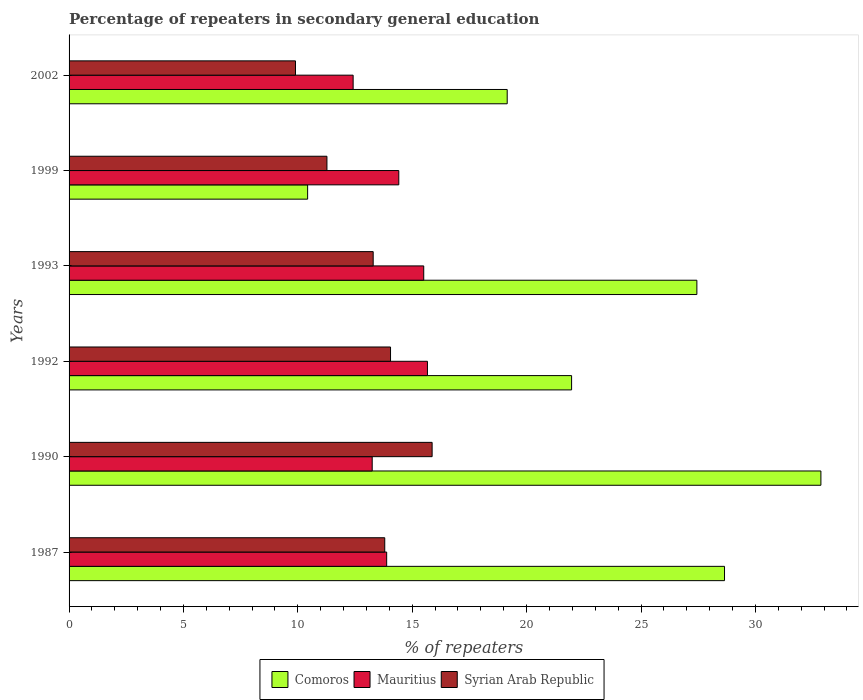How many different coloured bars are there?
Ensure brevity in your answer.  3. How many groups of bars are there?
Make the answer very short. 6. How many bars are there on the 2nd tick from the bottom?
Provide a short and direct response. 3. What is the percentage of repeaters in secondary general education in Syrian Arab Republic in 1992?
Make the answer very short. 14.05. Across all years, what is the maximum percentage of repeaters in secondary general education in Comoros?
Provide a succinct answer. 32.86. Across all years, what is the minimum percentage of repeaters in secondary general education in Mauritius?
Your response must be concise. 12.42. In which year was the percentage of repeaters in secondary general education in Syrian Arab Republic maximum?
Keep it short and to the point. 1990. In which year was the percentage of repeaters in secondary general education in Syrian Arab Republic minimum?
Give a very brief answer. 2002. What is the total percentage of repeaters in secondary general education in Comoros in the graph?
Provide a short and direct response. 140.5. What is the difference between the percentage of repeaters in secondary general education in Syrian Arab Republic in 1990 and that in 1999?
Offer a terse response. 4.6. What is the difference between the percentage of repeaters in secondary general education in Mauritius in 1990 and the percentage of repeaters in secondary general education in Comoros in 1992?
Offer a very short reply. -8.72. What is the average percentage of repeaters in secondary general education in Mauritius per year?
Offer a very short reply. 14.19. In the year 1987, what is the difference between the percentage of repeaters in secondary general education in Mauritius and percentage of repeaters in secondary general education in Syrian Arab Republic?
Provide a short and direct response. 0.08. What is the ratio of the percentage of repeaters in secondary general education in Comoros in 1992 to that in 1999?
Make the answer very short. 2.11. Is the percentage of repeaters in secondary general education in Syrian Arab Republic in 1990 less than that in 2002?
Your answer should be compact. No. What is the difference between the highest and the second highest percentage of repeaters in secondary general education in Syrian Arab Republic?
Make the answer very short. 1.82. What is the difference between the highest and the lowest percentage of repeaters in secondary general education in Comoros?
Offer a terse response. 22.44. Is the sum of the percentage of repeaters in secondary general education in Comoros in 1992 and 1993 greater than the maximum percentage of repeaters in secondary general education in Syrian Arab Republic across all years?
Your response must be concise. Yes. What does the 2nd bar from the top in 1993 represents?
Offer a very short reply. Mauritius. What does the 2nd bar from the bottom in 1999 represents?
Offer a terse response. Mauritius. Are all the bars in the graph horizontal?
Make the answer very short. Yes. How many years are there in the graph?
Provide a short and direct response. 6. What is the difference between two consecutive major ticks on the X-axis?
Give a very brief answer. 5. Does the graph contain grids?
Your answer should be very brief. No. How many legend labels are there?
Give a very brief answer. 3. What is the title of the graph?
Your response must be concise. Percentage of repeaters in secondary general education. Does "Djibouti" appear as one of the legend labels in the graph?
Provide a short and direct response. No. What is the label or title of the X-axis?
Keep it short and to the point. % of repeaters. What is the % of repeaters of Comoros in 1987?
Keep it short and to the point. 28.65. What is the % of repeaters in Mauritius in 1987?
Give a very brief answer. 13.88. What is the % of repeaters of Syrian Arab Republic in 1987?
Your answer should be very brief. 13.8. What is the % of repeaters in Comoros in 1990?
Your answer should be very brief. 32.86. What is the % of repeaters of Mauritius in 1990?
Offer a very short reply. 13.25. What is the % of repeaters of Syrian Arab Republic in 1990?
Offer a terse response. 15.87. What is the % of repeaters of Comoros in 1992?
Your response must be concise. 21.97. What is the % of repeaters in Mauritius in 1992?
Give a very brief answer. 15.67. What is the % of repeaters in Syrian Arab Republic in 1992?
Your response must be concise. 14.05. What is the % of repeaters of Comoros in 1993?
Provide a short and direct response. 27.44. What is the % of repeaters in Mauritius in 1993?
Give a very brief answer. 15.5. What is the % of repeaters in Syrian Arab Republic in 1993?
Ensure brevity in your answer.  13.29. What is the % of repeaters in Comoros in 1999?
Ensure brevity in your answer.  10.43. What is the % of repeaters in Mauritius in 1999?
Give a very brief answer. 14.41. What is the % of repeaters in Syrian Arab Republic in 1999?
Give a very brief answer. 11.27. What is the % of repeaters in Comoros in 2002?
Provide a short and direct response. 19.15. What is the % of repeaters in Mauritius in 2002?
Make the answer very short. 12.42. What is the % of repeaters of Syrian Arab Republic in 2002?
Make the answer very short. 9.9. Across all years, what is the maximum % of repeaters in Comoros?
Keep it short and to the point. 32.86. Across all years, what is the maximum % of repeaters of Mauritius?
Your answer should be compact. 15.67. Across all years, what is the maximum % of repeaters of Syrian Arab Republic?
Give a very brief answer. 15.87. Across all years, what is the minimum % of repeaters in Comoros?
Your answer should be very brief. 10.43. Across all years, what is the minimum % of repeaters of Mauritius?
Ensure brevity in your answer.  12.42. Across all years, what is the minimum % of repeaters in Syrian Arab Republic?
Your answer should be compact. 9.9. What is the total % of repeaters of Comoros in the graph?
Your answer should be very brief. 140.5. What is the total % of repeaters in Mauritius in the graph?
Make the answer very short. 85.13. What is the total % of repeaters of Syrian Arab Republic in the graph?
Keep it short and to the point. 78.18. What is the difference between the % of repeaters in Comoros in 1987 and that in 1990?
Offer a terse response. -4.21. What is the difference between the % of repeaters of Mauritius in 1987 and that in 1990?
Ensure brevity in your answer.  0.63. What is the difference between the % of repeaters in Syrian Arab Republic in 1987 and that in 1990?
Give a very brief answer. -2.07. What is the difference between the % of repeaters of Comoros in 1987 and that in 1992?
Offer a terse response. 6.68. What is the difference between the % of repeaters of Mauritius in 1987 and that in 1992?
Make the answer very short. -1.78. What is the difference between the % of repeaters in Syrian Arab Republic in 1987 and that in 1992?
Your answer should be very brief. -0.25. What is the difference between the % of repeaters of Comoros in 1987 and that in 1993?
Your answer should be compact. 1.21. What is the difference between the % of repeaters of Mauritius in 1987 and that in 1993?
Offer a terse response. -1.62. What is the difference between the % of repeaters of Syrian Arab Republic in 1987 and that in 1993?
Make the answer very short. 0.51. What is the difference between the % of repeaters of Comoros in 1987 and that in 1999?
Provide a short and direct response. 18.22. What is the difference between the % of repeaters in Mauritius in 1987 and that in 1999?
Offer a terse response. -0.53. What is the difference between the % of repeaters of Syrian Arab Republic in 1987 and that in 1999?
Offer a very short reply. 2.53. What is the difference between the % of repeaters of Comoros in 1987 and that in 2002?
Keep it short and to the point. 9.5. What is the difference between the % of repeaters of Mauritius in 1987 and that in 2002?
Offer a very short reply. 1.47. What is the difference between the % of repeaters of Syrian Arab Republic in 1987 and that in 2002?
Offer a very short reply. 3.9. What is the difference between the % of repeaters of Comoros in 1990 and that in 1992?
Offer a very short reply. 10.9. What is the difference between the % of repeaters of Mauritius in 1990 and that in 1992?
Give a very brief answer. -2.42. What is the difference between the % of repeaters in Syrian Arab Republic in 1990 and that in 1992?
Your response must be concise. 1.82. What is the difference between the % of repeaters of Comoros in 1990 and that in 1993?
Your answer should be compact. 5.42. What is the difference between the % of repeaters of Mauritius in 1990 and that in 1993?
Ensure brevity in your answer.  -2.25. What is the difference between the % of repeaters in Syrian Arab Republic in 1990 and that in 1993?
Give a very brief answer. 2.58. What is the difference between the % of repeaters in Comoros in 1990 and that in 1999?
Keep it short and to the point. 22.44. What is the difference between the % of repeaters in Mauritius in 1990 and that in 1999?
Make the answer very short. -1.16. What is the difference between the % of repeaters of Syrian Arab Republic in 1990 and that in 1999?
Make the answer very short. 4.6. What is the difference between the % of repeaters of Comoros in 1990 and that in 2002?
Give a very brief answer. 13.71. What is the difference between the % of repeaters in Mauritius in 1990 and that in 2002?
Your answer should be very brief. 0.83. What is the difference between the % of repeaters of Syrian Arab Republic in 1990 and that in 2002?
Your response must be concise. 5.97. What is the difference between the % of repeaters of Comoros in 1992 and that in 1993?
Provide a succinct answer. -5.48. What is the difference between the % of repeaters of Mauritius in 1992 and that in 1993?
Offer a terse response. 0.16. What is the difference between the % of repeaters in Syrian Arab Republic in 1992 and that in 1993?
Ensure brevity in your answer.  0.76. What is the difference between the % of repeaters of Comoros in 1992 and that in 1999?
Make the answer very short. 11.54. What is the difference between the % of repeaters in Mauritius in 1992 and that in 1999?
Offer a very short reply. 1.25. What is the difference between the % of repeaters in Syrian Arab Republic in 1992 and that in 1999?
Make the answer very short. 2.78. What is the difference between the % of repeaters in Comoros in 1992 and that in 2002?
Your answer should be very brief. 2.81. What is the difference between the % of repeaters of Mauritius in 1992 and that in 2002?
Provide a short and direct response. 3.25. What is the difference between the % of repeaters in Syrian Arab Republic in 1992 and that in 2002?
Offer a very short reply. 4.15. What is the difference between the % of repeaters in Comoros in 1993 and that in 1999?
Provide a succinct answer. 17.01. What is the difference between the % of repeaters in Mauritius in 1993 and that in 1999?
Keep it short and to the point. 1.09. What is the difference between the % of repeaters in Syrian Arab Republic in 1993 and that in 1999?
Keep it short and to the point. 2.02. What is the difference between the % of repeaters in Comoros in 1993 and that in 2002?
Your response must be concise. 8.29. What is the difference between the % of repeaters in Mauritius in 1993 and that in 2002?
Keep it short and to the point. 3.09. What is the difference between the % of repeaters of Syrian Arab Republic in 1993 and that in 2002?
Offer a terse response. 3.4. What is the difference between the % of repeaters in Comoros in 1999 and that in 2002?
Your response must be concise. -8.72. What is the difference between the % of repeaters of Mauritius in 1999 and that in 2002?
Keep it short and to the point. 2. What is the difference between the % of repeaters in Syrian Arab Republic in 1999 and that in 2002?
Keep it short and to the point. 1.38. What is the difference between the % of repeaters in Comoros in 1987 and the % of repeaters in Mauritius in 1990?
Offer a terse response. 15.4. What is the difference between the % of repeaters of Comoros in 1987 and the % of repeaters of Syrian Arab Republic in 1990?
Offer a terse response. 12.78. What is the difference between the % of repeaters in Mauritius in 1987 and the % of repeaters in Syrian Arab Republic in 1990?
Ensure brevity in your answer.  -1.99. What is the difference between the % of repeaters of Comoros in 1987 and the % of repeaters of Mauritius in 1992?
Provide a short and direct response. 12.98. What is the difference between the % of repeaters in Comoros in 1987 and the % of repeaters in Syrian Arab Republic in 1992?
Make the answer very short. 14.6. What is the difference between the % of repeaters in Mauritius in 1987 and the % of repeaters in Syrian Arab Republic in 1992?
Your answer should be very brief. -0.17. What is the difference between the % of repeaters in Comoros in 1987 and the % of repeaters in Mauritius in 1993?
Your response must be concise. 13.15. What is the difference between the % of repeaters of Comoros in 1987 and the % of repeaters of Syrian Arab Republic in 1993?
Your response must be concise. 15.36. What is the difference between the % of repeaters of Mauritius in 1987 and the % of repeaters of Syrian Arab Republic in 1993?
Keep it short and to the point. 0.59. What is the difference between the % of repeaters in Comoros in 1987 and the % of repeaters in Mauritius in 1999?
Provide a short and direct response. 14.24. What is the difference between the % of repeaters of Comoros in 1987 and the % of repeaters of Syrian Arab Republic in 1999?
Make the answer very short. 17.38. What is the difference between the % of repeaters in Mauritius in 1987 and the % of repeaters in Syrian Arab Republic in 1999?
Provide a short and direct response. 2.61. What is the difference between the % of repeaters of Comoros in 1987 and the % of repeaters of Mauritius in 2002?
Provide a succinct answer. 16.23. What is the difference between the % of repeaters of Comoros in 1987 and the % of repeaters of Syrian Arab Republic in 2002?
Make the answer very short. 18.75. What is the difference between the % of repeaters of Mauritius in 1987 and the % of repeaters of Syrian Arab Republic in 2002?
Keep it short and to the point. 3.99. What is the difference between the % of repeaters of Comoros in 1990 and the % of repeaters of Mauritius in 1992?
Provide a succinct answer. 17.2. What is the difference between the % of repeaters in Comoros in 1990 and the % of repeaters in Syrian Arab Republic in 1992?
Ensure brevity in your answer.  18.81. What is the difference between the % of repeaters in Mauritius in 1990 and the % of repeaters in Syrian Arab Republic in 1992?
Give a very brief answer. -0.8. What is the difference between the % of repeaters of Comoros in 1990 and the % of repeaters of Mauritius in 1993?
Give a very brief answer. 17.36. What is the difference between the % of repeaters of Comoros in 1990 and the % of repeaters of Syrian Arab Republic in 1993?
Your answer should be very brief. 19.57. What is the difference between the % of repeaters of Mauritius in 1990 and the % of repeaters of Syrian Arab Republic in 1993?
Offer a very short reply. -0.04. What is the difference between the % of repeaters in Comoros in 1990 and the % of repeaters in Mauritius in 1999?
Offer a terse response. 18.45. What is the difference between the % of repeaters of Comoros in 1990 and the % of repeaters of Syrian Arab Republic in 1999?
Offer a very short reply. 21.59. What is the difference between the % of repeaters in Mauritius in 1990 and the % of repeaters in Syrian Arab Republic in 1999?
Your answer should be compact. 1.98. What is the difference between the % of repeaters in Comoros in 1990 and the % of repeaters in Mauritius in 2002?
Offer a terse response. 20.45. What is the difference between the % of repeaters in Comoros in 1990 and the % of repeaters in Syrian Arab Republic in 2002?
Keep it short and to the point. 22.97. What is the difference between the % of repeaters of Mauritius in 1990 and the % of repeaters of Syrian Arab Republic in 2002?
Your answer should be very brief. 3.35. What is the difference between the % of repeaters of Comoros in 1992 and the % of repeaters of Mauritius in 1993?
Provide a short and direct response. 6.46. What is the difference between the % of repeaters in Comoros in 1992 and the % of repeaters in Syrian Arab Republic in 1993?
Your answer should be very brief. 8.67. What is the difference between the % of repeaters of Mauritius in 1992 and the % of repeaters of Syrian Arab Republic in 1993?
Offer a terse response. 2.37. What is the difference between the % of repeaters in Comoros in 1992 and the % of repeaters in Mauritius in 1999?
Your response must be concise. 7.55. What is the difference between the % of repeaters of Comoros in 1992 and the % of repeaters of Syrian Arab Republic in 1999?
Your response must be concise. 10.69. What is the difference between the % of repeaters in Mauritius in 1992 and the % of repeaters in Syrian Arab Republic in 1999?
Give a very brief answer. 4.39. What is the difference between the % of repeaters in Comoros in 1992 and the % of repeaters in Mauritius in 2002?
Your answer should be compact. 9.55. What is the difference between the % of repeaters of Comoros in 1992 and the % of repeaters of Syrian Arab Republic in 2002?
Keep it short and to the point. 12.07. What is the difference between the % of repeaters in Mauritius in 1992 and the % of repeaters in Syrian Arab Republic in 2002?
Your answer should be very brief. 5.77. What is the difference between the % of repeaters in Comoros in 1993 and the % of repeaters in Mauritius in 1999?
Keep it short and to the point. 13.03. What is the difference between the % of repeaters of Comoros in 1993 and the % of repeaters of Syrian Arab Republic in 1999?
Provide a short and direct response. 16.17. What is the difference between the % of repeaters of Mauritius in 1993 and the % of repeaters of Syrian Arab Republic in 1999?
Provide a short and direct response. 4.23. What is the difference between the % of repeaters in Comoros in 1993 and the % of repeaters in Mauritius in 2002?
Give a very brief answer. 15.03. What is the difference between the % of repeaters of Comoros in 1993 and the % of repeaters of Syrian Arab Republic in 2002?
Your answer should be very brief. 17.55. What is the difference between the % of repeaters of Mauritius in 1993 and the % of repeaters of Syrian Arab Republic in 2002?
Your response must be concise. 5.61. What is the difference between the % of repeaters in Comoros in 1999 and the % of repeaters in Mauritius in 2002?
Your answer should be compact. -1.99. What is the difference between the % of repeaters of Comoros in 1999 and the % of repeaters of Syrian Arab Republic in 2002?
Offer a terse response. 0.53. What is the difference between the % of repeaters of Mauritius in 1999 and the % of repeaters of Syrian Arab Republic in 2002?
Provide a short and direct response. 4.52. What is the average % of repeaters of Comoros per year?
Offer a very short reply. 23.42. What is the average % of repeaters of Mauritius per year?
Your answer should be compact. 14.19. What is the average % of repeaters of Syrian Arab Republic per year?
Offer a terse response. 13.03. In the year 1987, what is the difference between the % of repeaters of Comoros and % of repeaters of Mauritius?
Your answer should be very brief. 14.77. In the year 1987, what is the difference between the % of repeaters of Comoros and % of repeaters of Syrian Arab Republic?
Give a very brief answer. 14.85. In the year 1987, what is the difference between the % of repeaters in Mauritius and % of repeaters in Syrian Arab Republic?
Offer a very short reply. 0.08. In the year 1990, what is the difference between the % of repeaters of Comoros and % of repeaters of Mauritius?
Offer a very short reply. 19.61. In the year 1990, what is the difference between the % of repeaters in Comoros and % of repeaters in Syrian Arab Republic?
Make the answer very short. 16.99. In the year 1990, what is the difference between the % of repeaters in Mauritius and % of repeaters in Syrian Arab Republic?
Your answer should be very brief. -2.62. In the year 1992, what is the difference between the % of repeaters of Comoros and % of repeaters of Mauritius?
Offer a terse response. 6.3. In the year 1992, what is the difference between the % of repeaters in Comoros and % of repeaters in Syrian Arab Republic?
Provide a short and direct response. 7.91. In the year 1992, what is the difference between the % of repeaters of Mauritius and % of repeaters of Syrian Arab Republic?
Ensure brevity in your answer.  1.61. In the year 1993, what is the difference between the % of repeaters in Comoros and % of repeaters in Mauritius?
Give a very brief answer. 11.94. In the year 1993, what is the difference between the % of repeaters in Comoros and % of repeaters in Syrian Arab Republic?
Your answer should be very brief. 14.15. In the year 1993, what is the difference between the % of repeaters of Mauritius and % of repeaters of Syrian Arab Republic?
Offer a terse response. 2.21. In the year 1999, what is the difference between the % of repeaters of Comoros and % of repeaters of Mauritius?
Give a very brief answer. -3.99. In the year 1999, what is the difference between the % of repeaters in Comoros and % of repeaters in Syrian Arab Republic?
Give a very brief answer. -0.84. In the year 1999, what is the difference between the % of repeaters in Mauritius and % of repeaters in Syrian Arab Republic?
Ensure brevity in your answer.  3.14. In the year 2002, what is the difference between the % of repeaters in Comoros and % of repeaters in Mauritius?
Keep it short and to the point. 6.73. In the year 2002, what is the difference between the % of repeaters of Comoros and % of repeaters of Syrian Arab Republic?
Ensure brevity in your answer.  9.25. In the year 2002, what is the difference between the % of repeaters in Mauritius and % of repeaters in Syrian Arab Republic?
Offer a terse response. 2.52. What is the ratio of the % of repeaters of Comoros in 1987 to that in 1990?
Ensure brevity in your answer.  0.87. What is the ratio of the % of repeaters of Mauritius in 1987 to that in 1990?
Your answer should be compact. 1.05. What is the ratio of the % of repeaters in Syrian Arab Republic in 1987 to that in 1990?
Give a very brief answer. 0.87. What is the ratio of the % of repeaters in Comoros in 1987 to that in 1992?
Keep it short and to the point. 1.3. What is the ratio of the % of repeaters of Mauritius in 1987 to that in 1992?
Provide a succinct answer. 0.89. What is the ratio of the % of repeaters of Syrian Arab Republic in 1987 to that in 1992?
Make the answer very short. 0.98. What is the ratio of the % of repeaters of Comoros in 1987 to that in 1993?
Give a very brief answer. 1.04. What is the ratio of the % of repeaters in Mauritius in 1987 to that in 1993?
Your response must be concise. 0.9. What is the ratio of the % of repeaters in Syrian Arab Republic in 1987 to that in 1993?
Your answer should be compact. 1.04. What is the ratio of the % of repeaters in Comoros in 1987 to that in 1999?
Ensure brevity in your answer.  2.75. What is the ratio of the % of repeaters in Mauritius in 1987 to that in 1999?
Make the answer very short. 0.96. What is the ratio of the % of repeaters of Syrian Arab Republic in 1987 to that in 1999?
Make the answer very short. 1.22. What is the ratio of the % of repeaters of Comoros in 1987 to that in 2002?
Ensure brevity in your answer.  1.5. What is the ratio of the % of repeaters of Mauritius in 1987 to that in 2002?
Offer a very short reply. 1.12. What is the ratio of the % of repeaters of Syrian Arab Republic in 1987 to that in 2002?
Ensure brevity in your answer.  1.39. What is the ratio of the % of repeaters of Comoros in 1990 to that in 1992?
Make the answer very short. 1.5. What is the ratio of the % of repeaters in Mauritius in 1990 to that in 1992?
Your answer should be very brief. 0.85. What is the ratio of the % of repeaters of Syrian Arab Republic in 1990 to that in 1992?
Keep it short and to the point. 1.13. What is the ratio of the % of repeaters in Comoros in 1990 to that in 1993?
Offer a terse response. 1.2. What is the ratio of the % of repeaters of Mauritius in 1990 to that in 1993?
Give a very brief answer. 0.85. What is the ratio of the % of repeaters in Syrian Arab Republic in 1990 to that in 1993?
Your answer should be compact. 1.19. What is the ratio of the % of repeaters in Comoros in 1990 to that in 1999?
Give a very brief answer. 3.15. What is the ratio of the % of repeaters of Mauritius in 1990 to that in 1999?
Your response must be concise. 0.92. What is the ratio of the % of repeaters in Syrian Arab Republic in 1990 to that in 1999?
Ensure brevity in your answer.  1.41. What is the ratio of the % of repeaters of Comoros in 1990 to that in 2002?
Offer a very short reply. 1.72. What is the ratio of the % of repeaters in Mauritius in 1990 to that in 2002?
Provide a succinct answer. 1.07. What is the ratio of the % of repeaters of Syrian Arab Republic in 1990 to that in 2002?
Ensure brevity in your answer.  1.6. What is the ratio of the % of repeaters of Comoros in 1992 to that in 1993?
Your response must be concise. 0.8. What is the ratio of the % of repeaters of Mauritius in 1992 to that in 1993?
Make the answer very short. 1.01. What is the ratio of the % of repeaters of Syrian Arab Republic in 1992 to that in 1993?
Provide a succinct answer. 1.06. What is the ratio of the % of repeaters of Comoros in 1992 to that in 1999?
Your answer should be compact. 2.11. What is the ratio of the % of repeaters of Mauritius in 1992 to that in 1999?
Offer a terse response. 1.09. What is the ratio of the % of repeaters of Syrian Arab Republic in 1992 to that in 1999?
Your answer should be very brief. 1.25. What is the ratio of the % of repeaters of Comoros in 1992 to that in 2002?
Your answer should be very brief. 1.15. What is the ratio of the % of repeaters of Mauritius in 1992 to that in 2002?
Keep it short and to the point. 1.26. What is the ratio of the % of repeaters in Syrian Arab Republic in 1992 to that in 2002?
Keep it short and to the point. 1.42. What is the ratio of the % of repeaters of Comoros in 1993 to that in 1999?
Your answer should be very brief. 2.63. What is the ratio of the % of repeaters in Mauritius in 1993 to that in 1999?
Offer a very short reply. 1.08. What is the ratio of the % of repeaters of Syrian Arab Republic in 1993 to that in 1999?
Give a very brief answer. 1.18. What is the ratio of the % of repeaters of Comoros in 1993 to that in 2002?
Your answer should be compact. 1.43. What is the ratio of the % of repeaters of Mauritius in 1993 to that in 2002?
Offer a very short reply. 1.25. What is the ratio of the % of repeaters in Syrian Arab Republic in 1993 to that in 2002?
Give a very brief answer. 1.34. What is the ratio of the % of repeaters in Comoros in 1999 to that in 2002?
Keep it short and to the point. 0.54. What is the ratio of the % of repeaters in Mauritius in 1999 to that in 2002?
Give a very brief answer. 1.16. What is the ratio of the % of repeaters in Syrian Arab Republic in 1999 to that in 2002?
Ensure brevity in your answer.  1.14. What is the difference between the highest and the second highest % of repeaters of Comoros?
Offer a very short reply. 4.21. What is the difference between the highest and the second highest % of repeaters of Mauritius?
Your answer should be compact. 0.16. What is the difference between the highest and the second highest % of repeaters in Syrian Arab Republic?
Ensure brevity in your answer.  1.82. What is the difference between the highest and the lowest % of repeaters in Comoros?
Make the answer very short. 22.44. What is the difference between the highest and the lowest % of repeaters in Mauritius?
Your answer should be very brief. 3.25. What is the difference between the highest and the lowest % of repeaters of Syrian Arab Republic?
Your answer should be very brief. 5.97. 